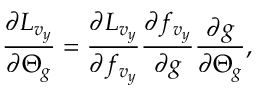<formula> <loc_0><loc_0><loc_500><loc_500>\frac { \partial L _ { v _ { y } } } { \partial \Theta _ { g } } = \frac { \partial L _ { v _ { y } } } { \partial f _ { v _ { y } } } \frac { \partial f _ { v _ { y } } } { \partial g } \frac { \partial g } { \partial \Theta _ { g } } ,</formula> 